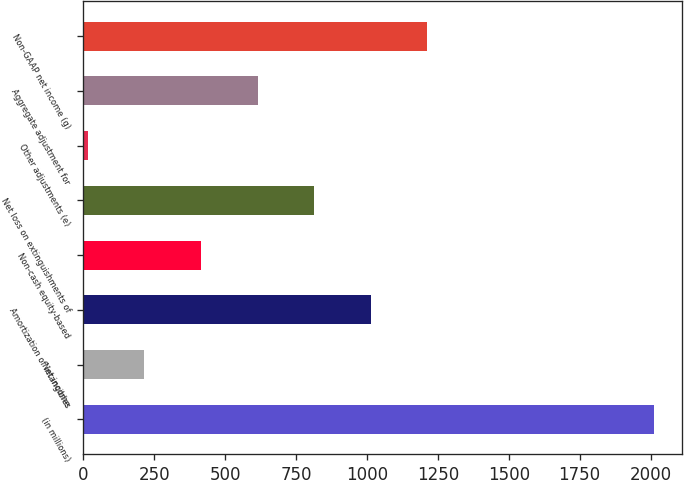Convert chart. <chart><loc_0><loc_0><loc_500><loc_500><bar_chart><fcel>(in millions)<fcel>Net income<fcel>Amortization of intangibles<fcel>Non-cash equity-based<fcel>Net loss on extinguishments of<fcel>Other adjustments (e)<fcel>Aggregate adjustment for<fcel>Non-GAAP net income (g)<nl><fcel>2011<fcel>215.14<fcel>1013.3<fcel>414.68<fcel>813.76<fcel>15.6<fcel>614.22<fcel>1212.84<nl></chart> 